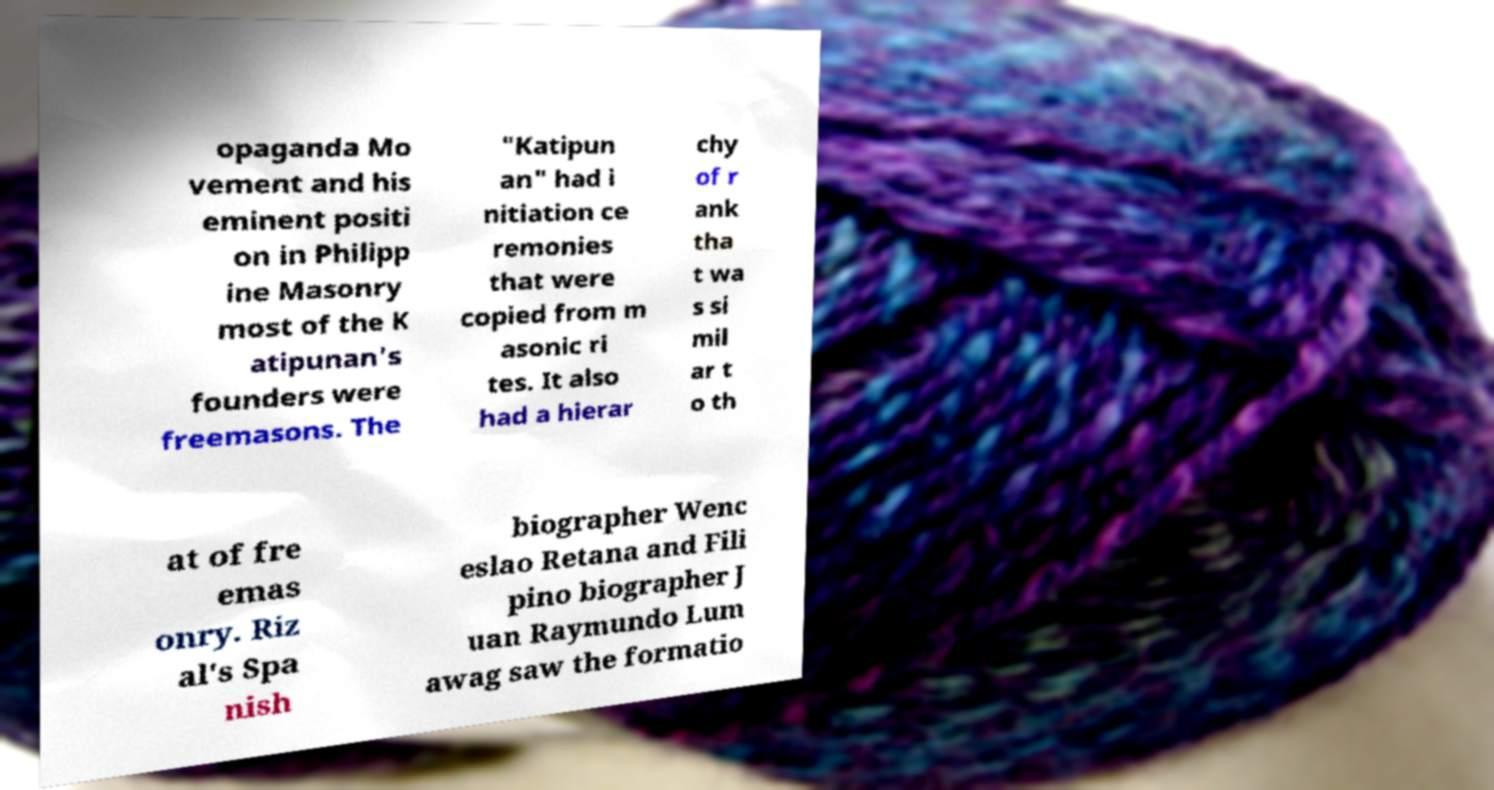Could you assist in decoding the text presented in this image and type it out clearly? opaganda Mo vement and his eminent positi on in Philipp ine Masonry most of the K atipunan's founders were freemasons. The "Katipun an" had i nitiation ce remonies that were copied from m asonic ri tes. It also had a hierar chy of r ank tha t wa s si mil ar t o th at of fre emas onry. Riz al's Spa nish biographer Wenc eslao Retana and Fili pino biographer J uan Raymundo Lum awag saw the formatio 